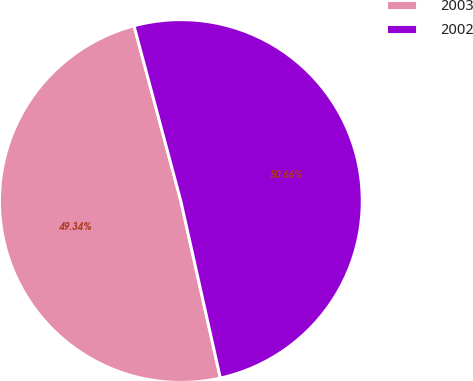Convert chart. <chart><loc_0><loc_0><loc_500><loc_500><pie_chart><fcel>2003<fcel>2002<nl><fcel>49.34%<fcel>50.66%<nl></chart> 